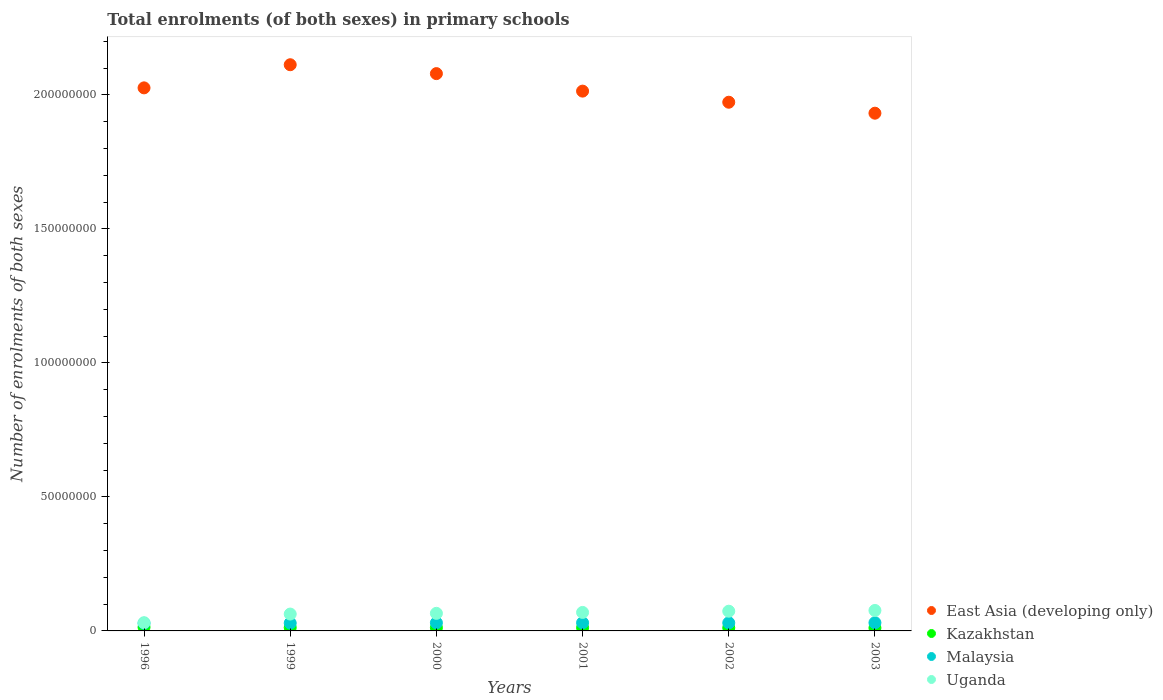How many different coloured dotlines are there?
Keep it short and to the point. 4. Is the number of dotlines equal to the number of legend labels?
Give a very brief answer. Yes. What is the number of enrolments in primary schools in Malaysia in 2000?
Your answer should be very brief. 3.03e+06. Across all years, what is the maximum number of enrolments in primary schools in Uganda?
Offer a very short reply. 7.63e+06. Across all years, what is the minimum number of enrolments in primary schools in Malaysia?
Provide a succinct answer. 2.86e+06. What is the total number of enrolments in primary schools in East Asia (developing only) in the graph?
Your answer should be very brief. 1.21e+09. What is the difference between the number of enrolments in primary schools in Kazakhstan in 1996 and that in 2000?
Provide a succinct answer. 1.64e+05. What is the difference between the number of enrolments in primary schools in Malaysia in 2002 and the number of enrolments in primary schools in Uganda in 2001?
Make the answer very short. -3.89e+06. What is the average number of enrolments in primary schools in East Asia (developing only) per year?
Keep it short and to the point. 2.02e+08. In the year 2002, what is the difference between the number of enrolments in primary schools in Kazakhstan and number of enrolments in primary schools in Uganda?
Give a very brief answer. -6.20e+06. What is the ratio of the number of enrolments in primary schools in Kazakhstan in 2002 to that in 2003?
Offer a terse response. 1.03. What is the difference between the highest and the second highest number of enrolments in primary schools in Uganda?
Ensure brevity in your answer.  2.79e+05. What is the difference between the highest and the lowest number of enrolments in primary schools in Uganda?
Your response must be concise. 4.56e+06. In how many years, is the number of enrolments in primary schools in Uganda greater than the average number of enrolments in primary schools in Uganda taken over all years?
Ensure brevity in your answer.  4. Does the number of enrolments in primary schools in Malaysia monotonically increase over the years?
Provide a short and direct response. No. Is the number of enrolments in primary schools in Uganda strictly greater than the number of enrolments in primary schools in Malaysia over the years?
Provide a short and direct response. Yes. Is the number of enrolments in primary schools in East Asia (developing only) strictly less than the number of enrolments in primary schools in Malaysia over the years?
Keep it short and to the point. No. How many years are there in the graph?
Give a very brief answer. 6. What is the difference between two consecutive major ticks on the Y-axis?
Offer a very short reply. 5.00e+07. Are the values on the major ticks of Y-axis written in scientific E-notation?
Ensure brevity in your answer.  No. Does the graph contain any zero values?
Your answer should be compact. No. Where does the legend appear in the graph?
Make the answer very short. Bottom right. What is the title of the graph?
Your response must be concise. Total enrolments (of both sexes) in primary schools. Does "Solomon Islands" appear as one of the legend labels in the graph?
Your response must be concise. No. What is the label or title of the X-axis?
Keep it short and to the point. Years. What is the label or title of the Y-axis?
Give a very brief answer. Number of enrolments of both sexes. What is the Number of enrolments of both sexes of East Asia (developing only) in 1996?
Provide a succinct answer. 2.03e+08. What is the Number of enrolments of both sexes of Kazakhstan in 1996?
Your answer should be very brief. 1.37e+06. What is the Number of enrolments of both sexes in Malaysia in 1996?
Give a very brief answer. 2.86e+06. What is the Number of enrolments of both sexes of Uganda in 1996?
Offer a terse response. 3.07e+06. What is the Number of enrolments of both sexes in East Asia (developing only) in 1999?
Keep it short and to the point. 2.11e+08. What is the Number of enrolments of both sexes of Kazakhstan in 1999?
Ensure brevity in your answer.  1.25e+06. What is the Number of enrolments of both sexes in Malaysia in 1999?
Offer a very short reply. 2.91e+06. What is the Number of enrolments of both sexes of Uganda in 1999?
Offer a very short reply. 6.29e+06. What is the Number of enrolments of both sexes of East Asia (developing only) in 2000?
Give a very brief answer. 2.08e+08. What is the Number of enrolments of both sexes of Kazakhstan in 2000?
Provide a succinct answer. 1.21e+06. What is the Number of enrolments of both sexes in Malaysia in 2000?
Keep it short and to the point. 3.03e+06. What is the Number of enrolments of both sexes in Uganda in 2000?
Provide a succinct answer. 6.56e+06. What is the Number of enrolments of both sexes in East Asia (developing only) in 2001?
Offer a terse response. 2.01e+08. What is the Number of enrolments of both sexes of Kazakhstan in 2001?
Give a very brief answer. 1.19e+06. What is the Number of enrolments of both sexes of Malaysia in 2001?
Ensure brevity in your answer.  3.03e+06. What is the Number of enrolments of both sexes in Uganda in 2001?
Make the answer very short. 6.90e+06. What is the Number of enrolments of both sexes in East Asia (developing only) in 2002?
Offer a very short reply. 1.97e+08. What is the Number of enrolments of both sexes in Kazakhstan in 2002?
Give a very brief answer. 1.16e+06. What is the Number of enrolments of both sexes in Malaysia in 2002?
Ensure brevity in your answer.  3.01e+06. What is the Number of enrolments of both sexes of Uganda in 2002?
Give a very brief answer. 7.35e+06. What is the Number of enrolments of both sexes in East Asia (developing only) in 2003?
Provide a succinct answer. 1.93e+08. What is the Number of enrolments of both sexes of Kazakhstan in 2003?
Keep it short and to the point. 1.12e+06. What is the Number of enrolments of both sexes in Malaysia in 2003?
Provide a short and direct response. 3.06e+06. What is the Number of enrolments of both sexes of Uganda in 2003?
Your answer should be compact. 7.63e+06. Across all years, what is the maximum Number of enrolments of both sexes of East Asia (developing only)?
Provide a succinct answer. 2.11e+08. Across all years, what is the maximum Number of enrolments of both sexes of Kazakhstan?
Ensure brevity in your answer.  1.37e+06. Across all years, what is the maximum Number of enrolments of both sexes of Malaysia?
Offer a terse response. 3.06e+06. Across all years, what is the maximum Number of enrolments of both sexes in Uganda?
Your answer should be compact. 7.63e+06. Across all years, what is the minimum Number of enrolments of both sexes of East Asia (developing only)?
Make the answer very short. 1.93e+08. Across all years, what is the minimum Number of enrolments of both sexes in Kazakhstan?
Your answer should be compact. 1.12e+06. Across all years, what is the minimum Number of enrolments of both sexes in Malaysia?
Your answer should be very brief. 2.86e+06. Across all years, what is the minimum Number of enrolments of both sexes of Uganda?
Keep it short and to the point. 3.07e+06. What is the total Number of enrolments of both sexes of East Asia (developing only) in the graph?
Offer a terse response. 1.21e+09. What is the total Number of enrolments of both sexes in Kazakhstan in the graph?
Ensure brevity in your answer.  7.30e+06. What is the total Number of enrolments of both sexes in Malaysia in the graph?
Your answer should be compact. 1.79e+07. What is the total Number of enrolments of both sexes of Uganda in the graph?
Offer a very short reply. 3.78e+07. What is the difference between the Number of enrolments of both sexes of East Asia (developing only) in 1996 and that in 1999?
Ensure brevity in your answer.  -8.63e+06. What is the difference between the Number of enrolments of both sexes in Kazakhstan in 1996 and that in 1999?
Provide a short and direct response. 1.24e+05. What is the difference between the Number of enrolments of both sexes in Malaysia in 1996 and that in 1999?
Your answer should be compact. -5.52e+04. What is the difference between the Number of enrolments of both sexes of Uganda in 1996 and that in 1999?
Your answer should be very brief. -3.22e+06. What is the difference between the Number of enrolments of both sexes in East Asia (developing only) in 1996 and that in 2000?
Give a very brief answer. -5.31e+06. What is the difference between the Number of enrolments of both sexes of Kazakhstan in 1996 and that in 2000?
Provide a succinct answer. 1.64e+05. What is the difference between the Number of enrolments of both sexes of Malaysia in 1996 and that in 2000?
Give a very brief answer. -1.69e+05. What is the difference between the Number of enrolments of both sexes of Uganda in 1996 and that in 2000?
Make the answer very short. -3.49e+06. What is the difference between the Number of enrolments of both sexes of East Asia (developing only) in 1996 and that in 2001?
Provide a short and direct response. 1.22e+06. What is the difference between the Number of enrolments of both sexes in Kazakhstan in 1996 and that in 2001?
Offer a very short reply. 1.83e+05. What is the difference between the Number of enrolments of both sexes of Malaysia in 1996 and that in 2001?
Provide a succinct answer. -1.76e+05. What is the difference between the Number of enrolments of both sexes of Uganda in 1996 and that in 2001?
Ensure brevity in your answer.  -3.83e+06. What is the difference between the Number of enrolments of both sexes of East Asia (developing only) in 1996 and that in 2002?
Your response must be concise. 5.36e+06. What is the difference between the Number of enrolments of both sexes of Kazakhstan in 1996 and that in 2002?
Provide a short and direct response. 2.14e+05. What is the difference between the Number of enrolments of both sexes of Malaysia in 1996 and that in 2002?
Offer a very short reply. -1.52e+05. What is the difference between the Number of enrolments of both sexes of Uganda in 1996 and that in 2002?
Provide a succinct answer. -4.29e+06. What is the difference between the Number of enrolments of both sexes of East Asia (developing only) in 1996 and that in 2003?
Ensure brevity in your answer.  9.45e+06. What is the difference between the Number of enrolments of both sexes in Kazakhstan in 1996 and that in 2003?
Provide a succinct answer. 2.53e+05. What is the difference between the Number of enrolments of both sexes in Malaysia in 1996 and that in 2003?
Provide a succinct answer. -2.00e+05. What is the difference between the Number of enrolments of both sexes in Uganda in 1996 and that in 2003?
Offer a very short reply. -4.56e+06. What is the difference between the Number of enrolments of both sexes in East Asia (developing only) in 1999 and that in 2000?
Provide a short and direct response. 3.31e+06. What is the difference between the Number of enrolments of both sexes of Kazakhstan in 1999 and that in 2000?
Make the answer very short. 4.06e+04. What is the difference between the Number of enrolments of both sexes in Malaysia in 1999 and that in 2000?
Give a very brief answer. -1.14e+05. What is the difference between the Number of enrolments of both sexes in Uganda in 1999 and that in 2000?
Your answer should be compact. -2.71e+05. What is the difference between the Number of enrolments of both sexes in East Asia (developing only) in 1999 and that in 2001?
Ensure brevity in your answer.  9.85e+06. What is the difference between the Number of enrolments of both sexes of Kazakhstan in 1999 and that in 2001?
Offer a very short reply. 5.88e+04. What is the difference between the Number of enrolments of both sexes in Malaysia in 1999 and that in 2001?
Your answer should be compact. -1.21e+05. What is the difference between the Number of enrolments of both sexes in Uganda in 1999 and that in 2001?
Give a very brief answer. -6.13e+05. What is the difference between the Number of enrolments of both sexes in East Asia (developing only) in 1999 and that in 2002?
Make the answer very short. 1.40e+07. What is the difference between the Number of enrolments of both sexes of Kazakhstan in 1999 and that in 2002?
Keep it short and to the point. 9.06e+04. What is the difference between the Number of enrolments of both sexes in Malaysia in 1999 and that in 2002?
Offer a very short reply. -9.72e+04. What is the difference between the Number of enrolments of both sexes of Uganda in 1999 and that in 2002?
Provide a succinct answer. -1.07e+06. What is the difference between the Number of enrolments of both sexes in East Asia (developing only) in 1999 and that in 2003?
Provide a short and direct response. 1.81e+07. What is the difference between the Number of enrolments of both sexes of Kazakhstan in 1999 and that in 2003?
Offer a terse response. 1.29e+05. What is the difference between the Number of enrolments of both sexes in Malaysia in 1999 and that in 2003?
Your answer should be compact. -1.44e+05. What is the difference between the Number of enrolments of both sexes of Uganda in 1999 and that in 2003?
Provide a short and direct response. -1.35e+06. What is the difference between the Number of enrolments of both sexes in East Asia (developing only) in 2000 and that in 2001?
Give a very brief answer. 6.53e+06. What is the difference between the Number of enrolments of both sexes in Kazakhstan in 2000 and that in 2001?
Give a very brief answer. 1.83e+04. What is the difference between the Number of enrolments of both sexes of Malaysia in 2000 and that in 2001?
Make the answer very short. -7042. What is the difference between the Number of enrolments of both sexes of Uganda in 2000 and that in 2001?
Keep it short and to the point. -3.42e+05. What is the difference between the Number of enrolments of both sexes of East Asia (developing only) in 2000 and that in 2002?
Provide a succinct answer. 1.07e+07. What is the difference between the Number of enrolments of both sexes in Kazakhstan in 2000 and that in 2002?
Ensure brevity in your answer.  5.00e+04. What is the difference between the Number of enrolments of both sexes in Malaysia in 2000 and that in 2002?
Offer a very short reply. 1.70e+04. What is the difference between the Number of enrolments of both sexes of Uganda in 2000 and that in 2002?
Provide a short and direct response. -7.95e+05. What is the difference between the Number of enrolments of both sexes of East Asia (developing only) in 2000 and that in 2003?
Offer a very short reply. 1.48e+07. What is the difference between the Number of enrolments of both sexes of Kazakhstan in 2000 and that in 2003?
Your answer should be compact. 8.83e+04. What is the difference between the Number of enrolments of both sexes of Malaysia in 2000 and that in 2003?
Make the answer very short. -3.03e+04. What is the difference between the Number of enrolments of both sexes in Uganda in 2000 and that in 2003?
Ensure brevity in your answer.  -1.07e+06. What is the difference between the Number of enrolments of both sexes of East Asia (developing only) in 2001 and that in 2002?
Make the answer very short. 4.14e+06. What is the difference between the Number of enrolments of both sexes of Kazakhstan in 2001 and that in 2002?
Keep it short and to the point. 3.18e+04. What is the difference between the Number of enrolments of both sexes of Malaysia in 2001 and that in 2002?
Your answer should be very brief. 2.40e+04. What is the difference between the Number of enrolments of both sexes in Uganda in 2001 and that in 2002?
Offer a terse response. -4.53e+05. What is the difference between the Number of enrolments of both sexes of East Asia (developing only) in 2001 and that in 2003?
Your answer should be very brief. 8.24e+06. What is the difference between the Number of enrolments of both sexes in Kazakhstan in 2001 and that in 2003?
Offer a terse response. 7.01e+04. What is the difference between the Number of enrolments of both sexes in Malaysia in 2001 and that in 2003?
Your response must be concise. -2.32e+04. What is the difference between the Number of enrolments of both sexes in Uganda in 2001 and that in 2003?
Ensure brevity in your answer.  -7.32e+05. What is the difference between the Number of enrolments of both sexes of East Asia (developing only) in 2002 and that in 2003?
Your answer should be very brief. 4.09e+06. What is the difference between the Number of enrolments of both sexes of Kazakhstan in 2002 and that in 2003?
Provide a short and direct response. 3.83e+04. What is the difference between the Number of enrolments of both sexes of Malaysia in 2002 and that in 2003?
Make the answer very short. -4.73e+04. What is the difference between the Number of enrolments of both sexes in Uganda in 2002 and that in 2003?
Offer a very short reply. -2.79e+05. What is the difference between the Number of enrolments of both sexes in East Asia (developing only) in 1996 and the Number of enrolments of both sexes in Kazakhstan in 1999?
Your answer should be compact. 2.01e+08. What is the difference between the Number of enrolments of both sexes of East Asia (developing only) in 1996 and the Number of enrolments of both sexes of Malaysia in 1999?
Your response must be concise. 2.00e+08. What is the difference between the Number of enrolments of both sexes in East Asia (developing only) in 1996 and the Number of enrolments of both sexes in Uganda in 1999?
Provide a succinct answer. 1.96e+08. What is the difference between the Number of enrolments of both sexes in Kazakhstan in 1996 and the Number of enrolments of both sexes in Malaysia in 1999?
Keep it short and to the point. -1.54e+06. What is the difference between the Number of enrolments of both sexes in Kazakhstan in 1996 and the Number of enrolments of both sexes in Uganda in 1999?
Your answer should be very brief. -4.92e+06. What is the difference between the Number of enrolments of both sexes of Malaysia in 1996 and the Number of enrolments of both sexes of Uganda in 1999?
Your response must be concise. -3.43e+06. What is the difference between the Number of enrolments of both sexes in East Asia (developing only) in 1996 and the Number of enrolments of both sexes in Kazakhstan in 2000?
Provide a succinct answer. 2.01e+08. What is the difference between the Number of enrolments of both sexes of East Asia (developing only) in 1996 and the Number of enrolments of both sexes of Malaysia in 2000?
Your answer should be very brief. 2.00e+08. What is the difference between the Number of enrolments of both sexes of East Asia (developing only) in 1996 and the Number of enrolments of both sexes of Uganda in 2000?
Offer a terse response. 1.96e+08. What is the difference between the Number of enrolments of both sexes of Kazakhstan in 1996 and the Number of enrolments of both sexes of Malaysia in 2000?
Offer a terse response. -1.65e+06. What is the difference between the Number of enrolments of both sexes of Kazakhstan in 1996 and the Number of enrolments of both sexes of Uganda in 2000?
Provide a succinct answer. -5.19e+06. What is the difference between the Number of enrolments of both sexes in Malaysia in 1996 and the Number of enrolments of both sexes in Uganda in 2000?
Your answer should be very brief. -3.70e+06. What is the difference between the Number of enrolments of both sexes in East Asia (developing only) in 1996 and the Number of enrolments of both sexes in Kazakhstan in 2001?
Ensure brevity in your answer.  2.01e+08. What is the difference between the Number of enrolments of both sexes of East Asia (developing only) in 1996 and the Number of enrolments of both sexes of Malaysia in 2001?
Offer a terse response. 2.00e+08. What is the difference between the Number of enrolments of both sexes in East Asia (developing only) in 1996 and the Number of enrolments of both sexes in Uganda in 2001?
Your answer should be compact. 1.96e+08. What is the difference between the Number of enrolments of both sexes in Kazakhstan in 1996 and the Number of enrolments of both sexes in Malaysia in 2001?
Offer a terse response. -1.66e+06. What is the difference between the Number of enrolments of both sexes in Kazakhstan in 1996 and the Number of enrolments of both sexes in Uganda in 2001?
Your answer should be compact. -5.53e+06. What is the difference between the Number of enrolments of both sexes in Malaysia in 1996 and the Number of enrolments of both sexes in Uganda in 2001?
Your answer should be very brief. -4.04e+06. What is the difference between the Number of enrolments of both sexes in East Asia (developing only) in 1996 and the Number of enrolments of both sexes in Kazakhstan in 2002?
Make the answer very short. 2.01e+08. What is the difference between the Number of enrolments of both sexes in East Asia (developing only) in 1996 and the Number of enrolments of both sexes in Malaysia in 2002?
Your response must be concise. 2.00e+08. What is the difference between the Number of enrolments of both sexes of East Asia (developing only) in 1996 and the Number of enrolments of both sexes of Uganda in 2002?
Ensure brevity in your answer.  1.95e+08. What is the difference between the Number of enrolments of both sexes in Kazakhstan in 1996 and the Number of enrolments of both sexes in Malaysia in 2002?
Provide a succinct answer. -1.64e+06. What is the difference between the Number of enrolments of both sexes of Kazakhstan in 1996 and the Number of enrolments of both sexes of Uganda in 2002?
Provide a short and direct response. -5.98e+06. What is the difference between the Number of enrolments of both sexes in Malaysia in 1996 and the Number of enrolments of both sexes in Uganda in 2002?
Offer a terse response. -4.50e+06. What is the difference between the Number of enrolments of both sexes of East Asia (developing only) in 1996 and the Number of enrolments of both sexes of Kazakhstan in 2003?
Ensure brevity in your answer.  2.01e+08. What is the difference between the Number of enrolments of both sexes of East Asia (developing only) in 1996 and the Number of enrolments of both sexes of Malaysia in 2003?
Offer a very short reply. 2.00e+08. What is the difference between the Number of enrolments of both sexes of East Asia (developing only) in 1996 and the Number of enrolments of both sexes of Uganda in 2003?
Your answer should be very brief. 1.95e+08. What is the difference between the Number of enrolments of both sexes of Kazakhstan in 1996 and the Number of enrolments of both sexes of Malaysia in 2003?
Provide a short and direct response. -1.68e+06. What is the difference between the Number of enrolments of both sexes of Kazakhstan in 1996 and the Number of enrolments of both sexes of Uganda in 2003?
Your response must be concise. -6.26e+06. What is the difference between the Number of enrolments of both sexes in Malaysia in 1996 and the Number of enrolments of both sexes in Uganda in 2003?
Keep it short and to the point. -4.78e+06. What is the difference between the Number of enrolments of both sexes of East Asia (developing only) in 1999 and the Number of enrolments of both sexes of Kazakhstan in 2000?
Your answer should be compact. 2.10e+08. What is the difference between the Number of enrolments of both sexes in East Asia (developing only) in 1999 and the Number of enrolments of both sexes in Malaysia in 2000?
Keep it short and to the point. 2.08e+08. What is the difference between the Number of enrolments of both sexes of East Asia (developing only) in 1999 and the Number of enrolments of both sexes of Uganda in 2000?
Your answer should be very brief. 2.05e+08. What is the difference between the Number of enrolments of both sexes in Kazakhstan in 1999 and the Number of enrolments of both sexes in Malaysia in 2000?
Your answer should be very brief. -1.78e+06. What is the difference between the Number of enrolments of both sexes of Kazakhstan in 1999 and the Number of enrolments of both sexes of Uganda in 2000?
Give a very brief answer. -5.31e+06. What is the difference between the Number of enrolments of both sexes of Malaysia in 1999 and the Number of enrolments of both sexes of Uganda in 2000?
Your answer should be very brief. -3.65e+06. What is the difference between the Number of enrolments of both sexes in East Asia (developing only) in 1999 and the Number of enrolments of both sexes in Kazakhstan in 2001?
Offer a very short reply. 2.10e+08. What is the difference between the Number of enrolments of both sexes of East Asia (developing only) in 1999 and the Number of enrolments of both sexes of Malaysia in 2001?
Offer a very short reply. 2.08e+08. What is the difference between the Number of enrolments of both sexes in East Asia (developing only) in 1999 and the Number of enrolments of both sexes in Uganda in 2001?
Make the answer very short. 2.04e+08. What is the difference between the Number of enrolments of both sexes in Kazakhstan in 1999 and the Number of enrolments of both sexes in Malaysia in 2001?
Provide a succinct answer. -1.78e+06. What is the difference between the Number of enrolments of both sexes in Kazakhstan in 1999 and the Number of enrolments of both sexes in Uganda in 2001?
Ensure brevity in your answer.  -5.65e+06. What is the difference between the Number of enrolments of both sexes in Malaysia in 1999 and the Number of enrolments of both sexes in Uganda in 2001?
Offer a terse response. -3.99e+06. What is the difference between the Number of enrolments of both sexes in East Asia (developing only) in 1999 and the Number of enrolments of both sexes in Kazakhstan in 2002?
Offer a terse response. 2.10e+08. What is the difference between the Number of enrolments of both sexes in East Asia (developing only) in 1999 and the Number of enrolments of both sexes in Malaysia in 2002?
Offer a very short reply. 2.08e+08. What is the difference between the Number of enrolments of both sexes of East Asia (developing only) in 1999 and the Number of enrolments of both sexes of Uganda in 2002?
Your answer should be compact. 2.04e+08. What is the difference between the Number of enrolments of both sexes of Kazakhstan in 1999 and the Number of enrolments of both sexes of Malaysia in 2002?
Provide a short and direct response. -1.76e+06. What is the difference between the Number of enrolments of both sexes of Kazakhstan in 1999 and the Number of enrolments of both sexes of Uganda in 2002?
Provide a succinct answer. -6.11e+06. What is the difference between the Number of enrolments of both sexes in Malaysia in 1999 and the Number of enrolments of both sexes in Uganda in 2002?
Your answer should be compact. -4.44e+06. What is the difference between the Number of enrolments of both sexes in East Asia (developing only) in 1999 and the Number of enrolments of both sexes in Kazakhstan in 2003?
Ensure brevity in your answer.  2.10e+08. What is the difference between the Number of enrolments of both sexes in East Asia (developing only) in 1999 and the Number of enrolments of both sexes in Malaysia in 2003?
Offer a very short reply. 2.08e+08. What is the difference between the Number of enrolments of both sexes of East Asia (developing only) in 1999 and the Number of enrolments of both sexes of Uganda in 2003?
Provide a succinct answer. 2.04e+08. What is the difference between the Number of enrolments of both sexes of Kazakhstan in 1999 and the Number of enrolments of both sexes of Malaysia in 2003?
Make the answer very short. -1.81e+06. What is the difference between the Number of enrolments of both sexes in Kazakhstan in 1999 and the Number of enrolments of both sexes in Uganda in 2003?
Provide a short and direct response. -6.38e+06. What is the difference between the Number of enrolments of both sexes of Malaysia in 1999 and the Number of enrolments of both sexes of Uganda in 2003?
Keep it short and to the point. -4.72e+06. What is the difference between the Number of enrolments of both sexes in East Asia (developing only) in 2000 and the Number of enrolments of both sexes in Kazakhstan in 2001?
Your answer should be very brief. 2.07e+08. What is the difference between the Number of enrolments of both sexes in East Asia (developing only) in 2000 and the Number of enrolments of both sexes in Malaysia in 2001?
Provide a succinct answer. 2.05e+08. What is the difference between the Number of enrolments of both sexes of East Asia (developing only) in 2000 and the Number of enrolments of both sexes of Uganda in 2001?
Provide a short and direct response. 2.01e+08. What is the difference between the Number of enrolments of both sexes of Kazakhstan in 2000 and the Number of enrolments of both sexes of Malaysia in 2001?
Keep it short and to the point. -1.82e+06. What is the difference between the Number of enrolments of both sexes in Kazakhstan in 2000 and the Number of enrolments of both sexes in Uganda in 2001?
Your answer should be compact. -5.69e+06. What is the difference between the Number of enrolments of both sexes of Malaysia in 2000 and the Number of enrolments of both sexes of Uganda in 2001?
Offer a very short reply. -3.87e+06. What is the difference between the Number of enrolments of both sexes of East Asia (developing only) in 2000 and the Number of enrolments of both sexes of Kazakhstan in 2002?
Make the answer very short. 2.07e+08. What is the difference between the Number of enrolments of both sexes of East Asia (developing only) in 2000 and the Number of enrolments of both sexes of Malaysia in 2002?
Make the answer very short. 2.05e+08. What is the difference between the Number of enrolments of both sexes of East Asia (developing only) in 2000 and the Number of enrolments of both sexes of Uganda in 2002?
Offer a very short reply. 2.01e+08. What is the difference between the Number of enrolments of both sexes in Kazakhstan in 2000 and the Number of enrolments of both sexes in Malaysia in 2002?
Offer a very short reply. -1.80e+06. What is the difference between the Number of enrolments of both sexes in Kazakhstan in 2000 and the Number of enrolments of both sexes in Uganda in 2002?
Ensure brevity in your answer.  -6.15e+06. What is the difference between the Number of enrolments of both sexes of Malaysia in 2000 and the Number of enrolments of both sexes of Uganda in 2002?
Give a very brief answer. -4.33e+06. What is the difference between the Number of enrolments of both sexes in East Asia (developing only) in 2000 and the Number of enrolments of both sexes in Kazakhstan in 2003?
Provide a succinct answer. 2.07e+08. What is the difference between the Number of enrolments of both sexes in East Asia (developing only) in 2000 and the Number of enrolments of both sexes in Malaysia in 2003?
Your answer should be very brief. 2.05e+08. What is the difference between the Number of enrolments of both sexes in East Asia (developing only) in 2000 and the Number of enrolments of both sexes in Uganda in 2003?
Make the answer very short. 2.00e+08. What is the difference between the Number of enrolments of both sexes in Kazakhstan in 2000 and the Number of enrolments of both sexes in Malaysia in 2003?
Give a very brief answer. -1.85e+06. What is the difference between the Number of enrolments of both sexes of Kazakhstan in 2000 and the Number of enrolments of both sexes of Uganda in 2003?
Give a very brief answer. -6.42e+06. What is the difference between the Number of enrolments of both sexes of Malaysia in 2000 and the Number of enrolments of both sexes of Uganda in 2003?
Your answer should be very brief. -4.61e+06. What is the difference between the Number of enrolments of both sexes of East Asia (developing only) in 2001 and the Number of enrolments of both sexes of Kazakhstan in 2002?
Offer a terse response. 2.00e+08. What is the difference between the Number of enrolments of both sexes in East Asia (developing only) in 2001 and the Number of enrolments of both sexes in Malaysia in 2002?
Make the answer very short. 1.98e+08. What is the difference between the Number of enrolments of both sexes of East Asia (developing only) in 2001 and the Number of enrolments of both sexes of Uganda in 2002?
Provide a short and direct response. 1.94e+08. What is the difference between the Number of enrolments of both sexes in Kazakhstan in 2001 and the Number of enrolments of both sexes in Malaysia in 2002?
Make the answer very short. -1.82e+06. What is the difference between the Number of enrolments of both sexes in Kazakhstan in 2001 and the Number of enrolments of both sexes in Uganda in 2002?
Keep it short and to the point. -6.16e+06. What is the difference between the Number of enrolments of both sexes of Malaysia in 2001 and the Number of enrolments of both sexes of Uganda in 2002?
Keep it short and to the point. -4.32e+06. What is the difference between the Number of enrolments of both sexes in East Asia (developing only) in 2001 and the Number of enrolments of both sexes in Kazakhstan in 2003?
Provide a short and direct response. 2.00e+08. What is the difference between the Number of enrolments of both sexes in East Asia (developing only) in 2001 and the Number of enrolments of both sexes in Malaysia in 2003?
Your answer should be compact. 1.98e+08. What is the difference between the Number of enrolments of both sexes in East Asia (developing only) in 2001 and the Number of enrolments of both sexes in Uganda in 2003?
Offer a terse response. 1.94e+08. What is the difference between the Number of enrolments of both sexes of Kazakhstan in 2001 and the Number of enrolments of both sexes of Malaysia in 2003?
Keep it short and to the point. -1.87e+06. What is the difference between the Number of enrolments of both sexes of Kazakhstan in 2001 and the Number of enrolments of both sexes of Uganda in 2003?
Your response must be concise. -6.44e+06. What is the difference between the Number of enrolments of both sexes of Malaysia in 2001 and the Number of enrolments of both sexes of Uganda in 2003?
Your answer should be very brief. -4.60e+06. What is the difference between the Number of enrolments of both sexes in East Asia (developing only) in 2002 and the Number of enrolments of both sexes in Kazakhstan in 2003?
Your answer should be compact. 1.96e+08. What is the difference between the Number of enrolments of both sexes of East Asia (developing only) in 2002 and the Number of enrolments of both sexes of Malaysia in 2003?
Your answer should be compact. 1.94e+08. What is the difference between the Number of enrolments of both sexes in East Asia (developing only) in 2002 and the Number of enrolments of both sexes in Uganda in 2003?
Your response must be concise. 1.90e+08. What is the difference between the Number of enrolments of both sexes in Kazakhstan in 2002 and the Number of enrolments of both sexes in Malaysia in 2003?
Offer a terse response. -1.90e+06. What is the difference between the Number of enrolments of both sexes in Kazakhstan in 2002 and the Number of enrolments of both sexes in Uganda in 2003?
Provide a short and direct response. -6.48e+06. What is the difference between the Number of enrolments of both sexes of Malaysia in 2002 and the Number of enrolments of both sexes of Uganda in 2003?
Your response must be concise. -4.62e+06. What is the average Number of enrolments of both sexes of East Asia (developing only) per year?
Your answer should be very brief. 2.02e+08. What is the average Number of enrolments of both sexes in Kazakhstan per year?
Offer a very short reply. 1.22e+06. What is the average Number of enrolments of both sexes of Malaysia per year?
Offer a terse response. 2.98e+06. What is the average Number of enrolments of both sexes in Uganda per year?
Offer a very short reply. 6.30e+06. In the year 1996, what is the difference between the Number of enrolments of both sexes of East Asia (developing only) and Number of enrolments of both sexes of Kazakhstan?
Keep it short and to the point. 2.01e+08. In the year 1996, what is the difference between the Number of enrolments of both sexes of East Asia (developing only) and Number of enrolments of both sexes of Malaysia?
Offer a terse response. 2.00e+08. In the year 1996, what is the difference between the Number of enrolments of both sexes in East Asia (developing only) and Number of enrolments of both sexes in Uganda?
Your answer should be compact. 2.00e+08. In the year 1996, what is the difference between the Number of enrolments of both sexes in Kazakhstan and Number of enrolments of both sexes in Malaysia?
Ensure brevity in your answer.  -1.48e+06. In the year 1996, what is the difference between the Number of enrolments of both sexes of Kazakhstan and Number of enrolments of both sexes of Uganda?
Give a very brief answer. -1.70e+06. In the year 1996, what is the difference between the Number of enrolments of both sexes of Malaysia and Number of enrolments of both sexes of Uganda?
Your answer should be compact. -2.12e+05. In the year 1999, what is the difference between the Number of enrolments of both sexes of East Asia (developing only) and Number of enrolments of both sexes of Kazakhstan?
Make the answer very short. 2.10e+08. In the year 1999, what is the difference between the Number of enrolments of both sexes of East Asia (developing only) and Number of enrolments of both sexes of Malaysia?
Offer a very short reply. 2.08e+08. In the year 1999, what is the difference between the Number of enrolments of both sexes of East Asia (developing only) and Number of enrolments of both sexes of Uganda?
Your response must be concise. 2.05e+08. In the year 1999, what is the difference between the Number of enrolments of both sexes in Kazakhstan and Number of enrolments of both sexes in Malaysia?
Your answer should be compact. -1.66e+06. In the year 1999, what is the difference between the Number of enrolments of both sexes in Kazakhstan and Number of enrolments of both sexes in Uganda?
Offer a terse response. -5.04e+06. In the year 1999, what is the difference between the Number of enrolments of both sexes of Malaysia and Number of enrolments of both sexes of Uganda?
Provide a short and direct response. -3.38e+06. In the year 2000, what is the difference between the Number of enrolments of both sexes in East Asia (developing only) and Number of enrolments of both sexes in Kazakhstan?
Ensure brevity in your answer.  2.07e+08. In the year 2000, what is the difference between the Number of enrolments of both sexes in East Asia (developing only) and Number of enrolments of both sexes in Malaysia?
Provide a succinct answer. 2.05e+08. In the year 2000, what is the difference between the Number of enrolments of both sexes in East Asia (developing only) and Number of enrolments of both sexes in Uganda?
Make the answer very short. 2.01e+08. In the year 2000, what is the difference between the Number of enrolments of both sexes in Kazakhstan and Number of enrolments of both sexes in Malaysia?
Give a very brief answer. -1.82e+06. In the year 2000, what is the difference between the Number of enrolments of both sexes in Kazakhstan and Number of enrolments of both sexes in Uganda?
Give a very brief answer. -5.35e+06. In the year 2000, what is the difference between the Number of enrolments of both sexes in Malaysia and Number of enrolments of both sexes in Uganda?
Offer a very short reply. -3.53e+06. In the year 2001, what is the difference between the Number of enrolments of both sexes in East Asia (developing only) and Number of enrolments of both sexes in Kazakhstan?
Your answer should be compact. 2.00e+08. In the year 2001, what is the difference between the Number of enrolments of both sexes in East Asia (developing only) and Number of enrolments of both sexes in Malaysia?
Offer a very short reply. 1.98e+08. In the year 2001, what is the difference between the Number of enrolments of both sexes of East Asia (developing only) and Number of enrolments of both sexes of Uganda?
Your response must be concise. 1.94e+08. In the year 2001, what is the difference between the Number of enrolments of both sexes in Kazakhstan and Number of enrolments of both sexes in Malaysia?
Offer a very short reply. -1.84e+06. In the year 2001, what is the difference between the Number of enrolments of both sexes of Kazakhstan and Number of enrolments of both sexes of Uganda?
Give a very brief answer. -5.71e+06. In the year 2001, what is the difference between the Number of enrolments of both sexes of Malaysia and Number of enrolments of both sexes of Uganda?
Your response must be concise. -3.87e+06. In the year 2002, what is the difference between the Number of enrolments of both sexes of East Asia (developing only) and Number of enrolments of both sexes of Kazakhstan?
Make the answer very short. 1.96e+08. In the year 2002, what is the difference between the Number of enrolments of both sexes of East Asia (developing only) and Number of enrolments of both sexes of Malaysia?
Give a very brief answer. 1.94e+08. In the year 2002, what is the difference between the Number of enrolments of both sexes in East Asia (developing only) and Number of enrolments of both sexes in Uganda?
Your response must be concise. 1.90e+08. In the year 2002, what is the difference between the Number of enrolments of both sexes of Kazakhstan and Number of enrolments of both sexes of Malaysia?
Provide a short and direct response. -1.85e+06. In the year 2002, what is the difference between the Number of enrolments of both sexes in Kazakhstan and Number of enrolments of both sexes in Uganda?
Make the answer very short. -6.20e+06. In the year 2002, what is the difference between the Number of enrolments of both sexes in Malaysia and Number of enrolments of both sexes in Uganda?
Offer a terse response. -4.35e+06. In the year 2003, what is the difference between the Number of enrolments of both sexes of East Asia (developing only) and Number of enrolments of both sexes of Kazakhstan?
Offer a very short reply. 1.92e+08. In the year 2003, what is the difference between the Number of enrolments of both sexes in East Asia (developing only) and Number of enrolments of both sexes in Malaysia?
Provide a short and direct response. 1.90e+08. In the year 2003, what is the difference between the Number of enrolments of both sexes in East Asia (developing only) and Number of enrolments of both sexes in Uganda?
Give a very brief answer. 1.86e+08. In the year 2003, what is the difference between the Number of enrolments of both sexes of Kazakhstan and Number of enrolments of both sexes of Malaysia?
Make the answer very short. -1.94e+06. In the year 2003, what is the difference between the Number of enrolments of both sexes of Kazakhstan and Number of enrolments of both sexes of Uganda?
Offer a terse response. -6.51e+06. In the year 2003, what is the difference between the Number of enrolments of both sexes in Malaysia and Number of enrolments of both sexes in Uganda?
Ensure brevity in your answer.  -4.58e+06. What is the ratio of the Number of enrolments of both sexes of East Asia (developing only) in 1996 to that in 1999?
Make the answer very short. 0.96. What is the ratio of the Number of enrolments of both sexes in Kazakhstan in 1996 to that in 1999?
Your answer should be very brief. 1.1. What is the ratio of the Number of enrolments of both sexes in Malaysia in 1996 to that in 1999?
Offer a very short reply. 0.98. What is the ratio of the Number of enrolments of both sexes in Uganda in 1996 to that in 1999?
Ensure brevity in your answer.  0.49. What is the ratio of the Number of enrolments of both sexes in East Asia (developing only) in 1996 to that in 2000?
Your answer should be compact. 0.97. What is the ratio of the Number of enrolments of both sexes in Kazakhstan in 1996 to that in 2000?
Your response must be concise. 1.14. What is the ratio of the Number of enrolments of both sexes of Malaysia in 1996 to that in 2000?
Your answer should be very brief. 0.94. What is the ratio of the Number of enrolments of both sexes in Uganda in 1996 to that in 2000?
Make the answer very short. 0.47. What is the ratio of the Number of enrolments of both sexes in Kazakhstan in 1996 to that in 2001?
Make the answer very short. 1.15. What is the ratio of the Number of enrolments of both sexes in Malaysia in 1996 to that in 2001?
Make the answer very short. 0.94. What is the ratio of the Number of enrolments of both sexes in Uganda in 1996 to that in 2001?
Offer a terse response. 0.44. What is the ratio of the Number of enrolments of both sexes of East Asia (developing only) in 1996 to that in 2002?
Offer a terse response. 1.03. What is the ratio of the Number of enrolments of both sexes of Kazakhstan in 1996 to that in 2002?
Offer a very short reply. 1.19. What is the ratio of the Number of enrolments of both sexes of Malaysia in 1996 to that in 2002?
Your response must be concise. 0.95. What is the ratio of the Number of enrolments of both sexes of Uganda in 1996 to that in 2002?
Your answer should be compact. 0.42. What is the ratio of the Number of enrolments of both sexes of East Asia (developing only) in 1996 to that in 2003?
Your answer should be compact. 1.05. What is the ratio of the Number of enrolments of both sexes in Kazakhstan in 1996 to that in 2003?
Ensure brevity in your answer.  1.23. What is the ratio of the Number of enrolments of both sexes in Malaysia in 1996 to that in 2003?
Your response must be concise. 0.93. What is the ratio of the Number of enrolments of both sexes in Uganda in 1996 to that in 2003?
Give a very brief answer. 0.4. What is the ratio of the Number of enrolments of both sexes of East Asia (developing only) in 1999 to that in 2000?
Give a very brief answer. 1.02. What is the ratio of the Number of enrolments of both sexes in Kazakhstan in 1999 to that in 2000?
Your answer should be compact. 1.03. What is the ratio of the Number of enrolments of both sexes of Malaysia in 1999 to that in 2000?
Keep it short and to the point. 0.96. What is the ratio of the Number of enrolments of both sexes in Uganda in 1999 to that in 2000?
Offer a very short reply. 0.96. What is the ratio of the Number of enrolments of both sexes of East Asia (developing only) in 1999 to that in 2001?
Ensure brevity in your answer.  1.05. What is the ratio of the Number of enrolments of both sexes of Kazakhstan in 1999 to that in 2001?
Keep it short and to the point. 1.05. What is the ratio of the Number of enrolments of both sexes of Uganda in 1999 to that in 2001?
Offer a very short reply. 0.91. What is the ratio of the Number of enrolments of both sexes in East Asia (developing only) in 1999 to that in 2002?
Offer a very short reply. 1.07. What is the ratio of the Number of enrolments of both sexes in Kazakhstan in 1999 to that in 2002?
Keep it short and to the point. 1.08. What is the ratio of the Number of enrolments of both sexes of Uganda in 1999 to that in 2002?
Offer a terse response. 0.86. What is the ratio of the Number of enrolments of both sexes of East Asia (developing only) in 1999 to that in 2003?
Provide a short and direct response. 1.09. What is the ratio of the Number of enrolments of both sexes in Kazakhstan in 1999 to that in 2003?
Ensure brevity in your answer.  1.12. What is the ratio of the Number of enrolments of both sexes of Malaysia in 1999 to that in 2003?
Make the answer very short. 0.95. What is the ratio of the Number of enrolments of both sexes in Uganda in 1999 to that in 2003?
Ensure brevity in your answer.  0.82. What is the ratio of the Number of enrolments of both sexes of East Asia (developing only) in 2000 to that in 2001?
Provide a short and direct response. 1.03. What is the ratio of the Number of enrolments of both sexes of Kazakhstan in 2000 to that in 2001?
Offer a terse response. 1.02. What is the ratio of the Number of enrolments of both sexes in Uganda in 2000 to that in 2001?
Keep it short and to the point. 0.95. What is the ratio of the Number of enrolments of both sexes in East Asia (developing only) in 2000 to that in 2002?
Make the answer very short. 1.05. What is the ratio of the Number of enrolments of both sexes in Kazakhstan in 2000 to that in 2002?
Make the answer very short. 1.04. What is the ratio of the Number of enrolments of both sexes in Malaysia in 2000 to that in 2002?
Keep it short and to the point. 1.01. What is the ratio of the Number of enrolments of both sexes of Uganda in 2000 to that in 2002?
Offer a very short reply. 0.89. What is the ratio of the Number of enrolments of both sexes in East Asia (developing only) in 2000 to that in 2003?
Provide a succinct answer. 1.08. What is the ratio of the Number of enrolments of both sexes in Kazakhstan in 2000 to that in 2003?
Provide a succinct answer. 1.08. What is the ratio of the Number of enrolments of both sexes of Malaysia in 2000 to that in 2003?
Ensure brevity in your answer.  0.99. What is the ratio of the Number of enrolments of both sexes in Uganda in 2000 to that in 2003?
Your answer should be compact. 0.86. What is the ratio of the Number of enrolments of both sexes in Kazakhstan in 2001 to that in 2002?
Your response must be concise. 1.03. What is the ratio of the Number of enrolments of both sexes of Uganda in 2001 to that in 2002?
Your answer should be compact. 0.94. What is the ratio of the Number of enrolments of both sexes in East Asia (developing only) in 2001 to that in 2003?
Make the answer very short. 1.04. What is the ratio of the Number of enrolments of both sexes in Kazakhstan in 2001 to that in 2003?
Provide a short and direct response. 1.06. What is the ratio of the Number of enrolments of both sexes of Malaysia in 2001 to that in 2003?
Offer a very short reply. 0.99. What is the ratio of the Number of enrolments of both sexes of Uganda in 2001 to that in 2003?
Keep it short and to the point. 0.9. What is the ratio of the Number of enrolments of both sexes in East Asia (developing only) in 2002 to that in 2003?
Provide a succinct answer. 1.02. What is the ratio of the Number of enrolments of both sexes in Kazakhstan in 2002 to that in 2003?
Offer a very short reply. 1.03. What is the ratio of the Number of enrolments of both sexes in Malaysia in 2002 to that in 2003?
Your answer should be compact. 0.98. What is the ratio of the Number of enrolments of both sexes in Uganda in 2002 to that in 2003?
Provide a short and direct response. 0.96. What is the difference between the highest and the second highest Number of enrolments of both sexes of East Asia (developing only)?
Provide a succinct answer. 3.31e+06. What is the difference between the highest and the second highest Number of enrolments of both sexes of Kazakhstan?
Ensure brevity in your answer.  1.24e+05. What is the difference between the highest and the second highest Number of enrolments of both sexes of Malaysia?
Make the answer very short. 2.32e+04. What is the difference between the highest and the second highest Number of enrolments of both sexes of Uganda?
Provide a succinct answer. 2.79e+05. What is the difference between the highest and the lowest Number of enrolments of both sexes of East Asia (developing only)?
Your answer should be compact. 1.81e+07. What is the difference between the highest and the lowest Number of enrolments of both sexes in Kazakhstan?
Keep it short and to the point. 2.53e+05. What is the difference between the highest and the lowest Number of enrolments of both sexes in Malaysia?
Make the answer very short. 2.00e+05. What is the difference between the highest and the lowest Number of enrolments of both sexes of Uganda?
Offer a very short reply. 4.56e+06. 